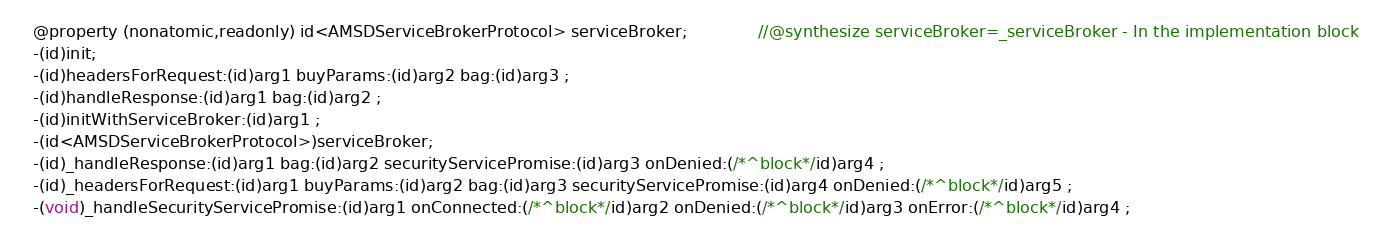Convert code to text. <code><loc_0><loc_0><loc_500><loc_500><_C_>
@property (nonatomic,readonly) id<AMSDServiceBrokerProtocol> serviceBroker;              //@synthesize serviceBroker=_serviceBroker - In the implementation block
-(id)init;
-(id)headersForRequest:(id)arg1 buyParams:(id)arg2 bag:(id)arg3 ;
-(id)handleResponse:(id)arg1 bag:(id)arg2 ;
-(id)initWithServiceBroker:(id)arg1 ;
-(id<AMSDServiceBrokerProtocol>)serviceBroker;
-(id)_handleResponse:(id)arg1 bag:(id)arg2 securityServicePromise:(id)arg3 onDenied:(/*^block*/id)arg4 ;
-(id)_headersForRequest:(id)arg1 buyParams:(id)arg2 bag:(id)arg3 securityServicePromise:(id)arg4 onDenied:(/*^block*/id)arg5 ;
-(void)_handleSecurityServicePromise:(id)arg1 onConnected:(/*^block*/id)arg2 onDenied:(/*^block*/id)arg3 onError:(/*^block*/id)arg4 ;</code> 